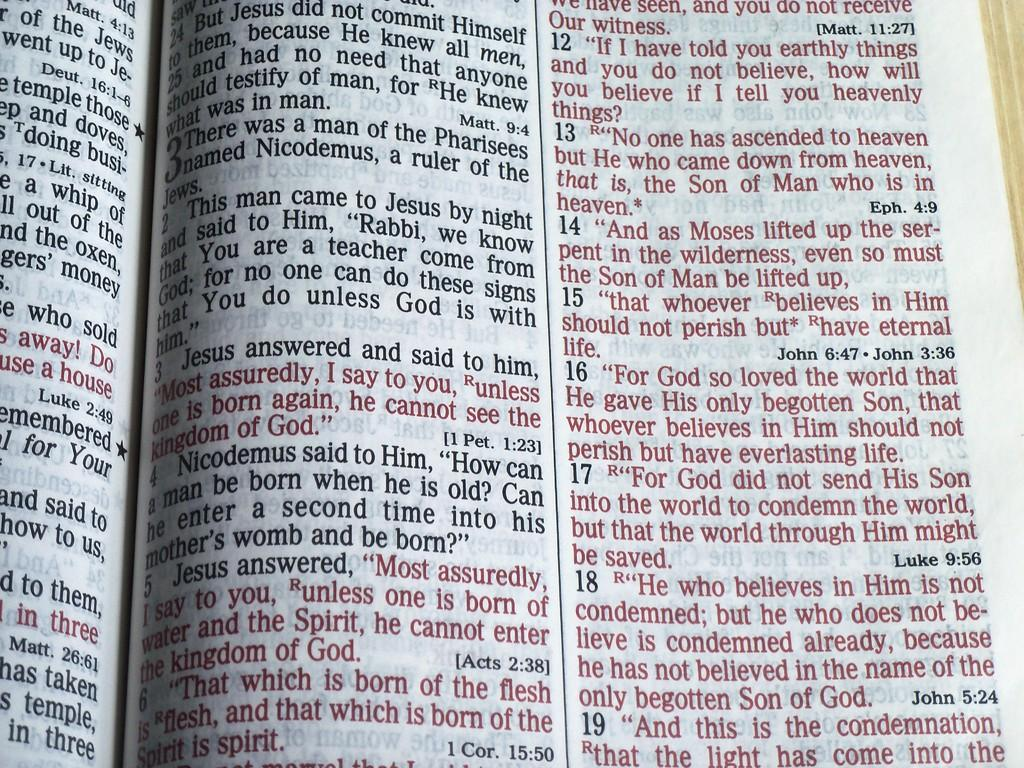<image>
Render a clear and concise summary of the photo. Page from a Bible with red words that come from "Luke 9:56". 